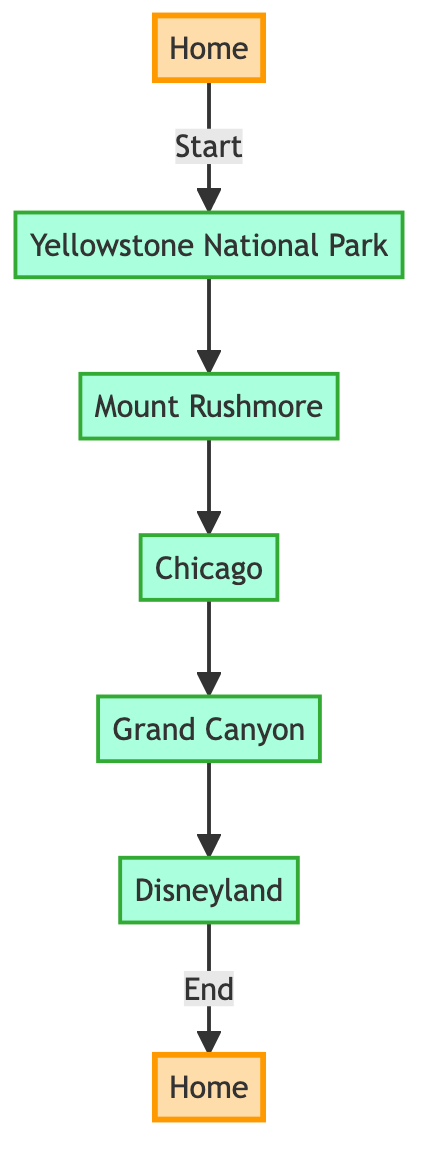What is the starting point of the road trip? The starting point is represented by the first node in the diagram, labeled "Home". This is indicated by the arrow showing the direction from "Home" to the next attraction, Yellowstone National Park.
Answer: Home How many stops are there before reaching Disneyland? Counting the nodes from the starting point to Disneyland, there are five stops: Yellowstone National Park, Mount Rushmore, Chicago, Grand Canyon, and Disneyland itself.
Answer: 5 What is the location of Mount Rushmore? The diagram includes a description next to the node labeled "Mount Rushmore", which clearly states that its location is "South Dakota".
Answer: South Dakota Which attraction is known for its geysers? Upon reviewing the nodes in the diagram, Yellowstone National Park is specifically mentioned as famous for its geysers and hot springs. Thus, it corresponds to the description provided in the diagram.
Answer: Yellowstone National Park What is the endpoint of the road trip? The endpoint is represented by the last node in the diagram, which is also labeled "Home". This is indicated as the final destination in the road trip, marked with an arrow leading to it from Disneyland.
Answer: Home Which city is known for deep-dish pizza? In the diagram, the node labeled "Chicago" has a description mentioning that it is known for its architecture and deep-dish pizza. Thus, this answers the question directly.
Answer: Chicago What is the last attraction before returning home? Looking at the flow in the diagram, the last attraction before returning to the starting point is Disneyland, as it directly precedes the endpoint labeled "Home".
Answer: Disneyland List one natural wonder mentioned in the stops. The Grand Canyon is explicitly described in the diagram as one of the world’s natural wonders, pinpointing its significance among the attractions listed.
Answer: Grand Canyon Which state is home to the Grand Canyon? The node for the Grand Canyon in the diagram indicates that it is located in Arizona, thus directly answering the question about its state.
Answer: Arizona 